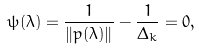<formula> <loc_0><loc_0><loc_500><loc_500>\psi ( \lambda ) = \frac { 1 } { \| p ( \lambda ) \| } - \frac { 1 } { \Delta _ { k } } = 0 ,</formula> 